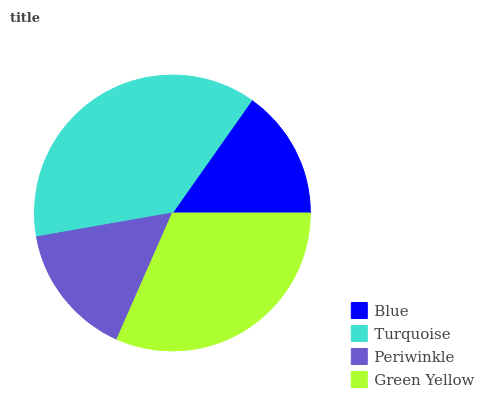Is Blue the minimum?
Answer yes or no. Yes. Is Turquoise the maximum?
Answer yes or no. Yes. Is Periwinkle the minimum?
Answer yes or no. No. Is Periwinkle the maximum?
Answer yes or no. No. Is Turquoise greater than Periwinkle?
Answer yes or no. Yes. Is Periwinkle less than Turquoise?
Answer yes or no. Yes. Is Periwinkle greater than Turquoise?
Answer yes or no. No. Is Turquoise less than Periwinkle?
Answer yes or no. No. Is Green Yellow the high median?
Answer yes or no. Yes. Is Periwinkle the low median?
Answer yes or no. Yes. Is Turquoise the high median?
Answer yes or no. No. Is Turquoise the low median?
Answer yes or no. No. 